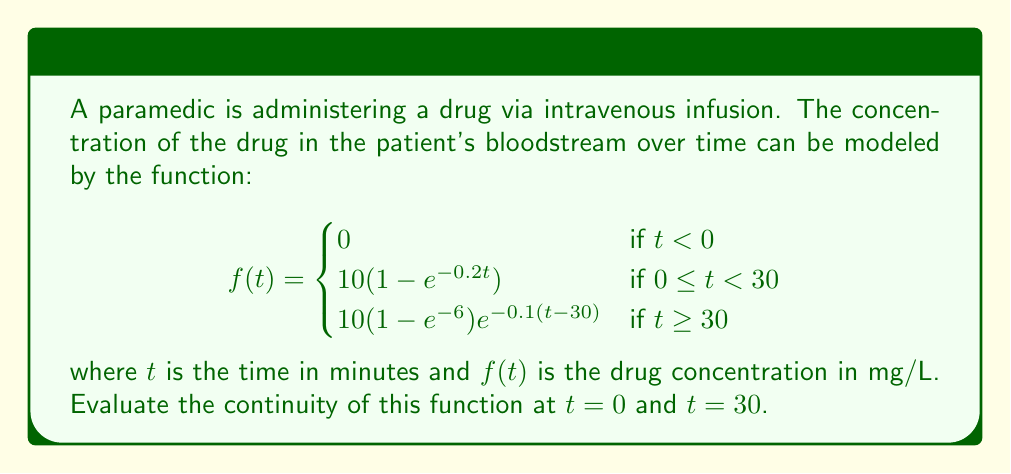Give your solution to this math problem. To evaluate the continuity of the function at $t = 0$ and $t = 30$, we need to check three conditions at each point:

1. The function must be defined at the point.
2. The limit of the function as we approach the point from both sides must exist.
3. The limit must equal the function value at that point.

At $t = 0$:

1. The function is defined at $t = 0$: $f(0) = 10(1-e^{-0.2(0)}) = 10(1-1) = 0$

2. Left-hand limit:
   $\lim_{t \to 0^-} f(t) = \lim_{t \to 0^-} 0 = 0$
   
   Right-hand limit:
   $\lim_{t \to 0^+} f(t) = \lim_{t \to 0^+} 10(1-e^{-0.2t}) = 10(1-e^0) = 0$

3. $\lim_{t \to 0} f(t) = f(0) = 0$

All three conditions are satisfied, so the function is continuous at $t = 0$.

At $t = 30$:

1. The function is defined at $t = 30$:
   $f(30) = 10(1-e^{-0.2(30)}) = 10(1-e^{-6})$

2. Left-hand limit:
   $\lim_{t \to 30^-} f(t) = \lim_{t \to 30^-} 10(1-e^{-0.2t}) = 10(1-e^{-6})$
   
   Right-hand limit:
   $\lim_{t \to 30^+} f(t) = \lim_{t \to 30^+} 10(1-e^{-6})e^{-0.1(t-30)} = 10(1-e^{-6})$

3. $\lim_{t \to 30} f(t) = f(30) = 10(1-e^{-6})$

All three conditions are satisfied, so the function is continuous at $t = 30$.
Answer: The function $f(t)$ is continuous at both $t = 0$ and $t = 30$. 